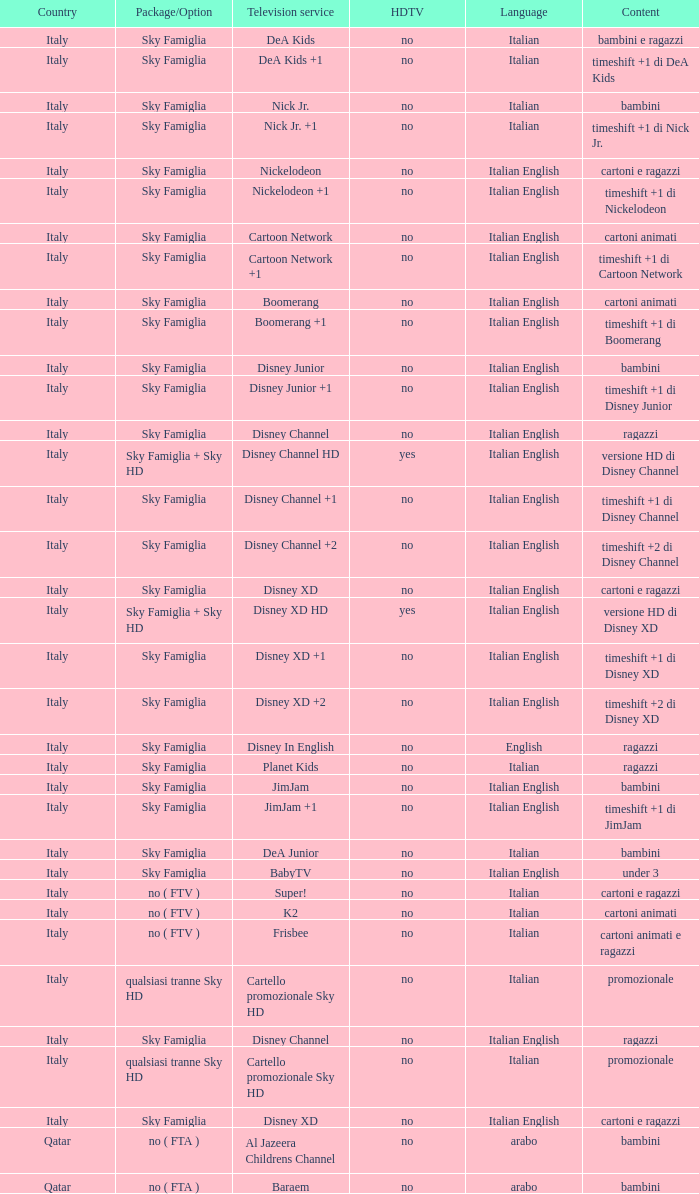What is the Country when the language is italian english, and the television service is disney xd +1? Italy. 